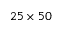Convert formula to latex. <formula><loc_0><loc_0><loc_500><loc_500>2 5 \times 5 0</formula> 